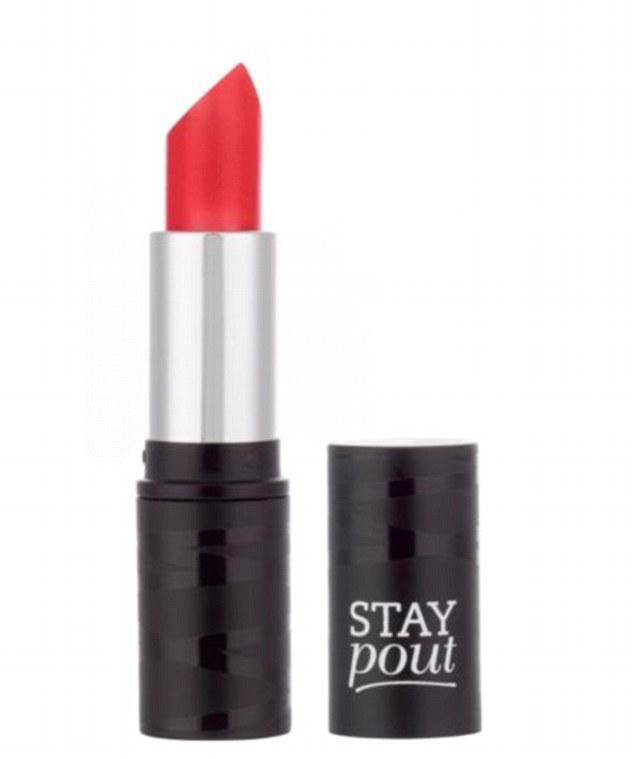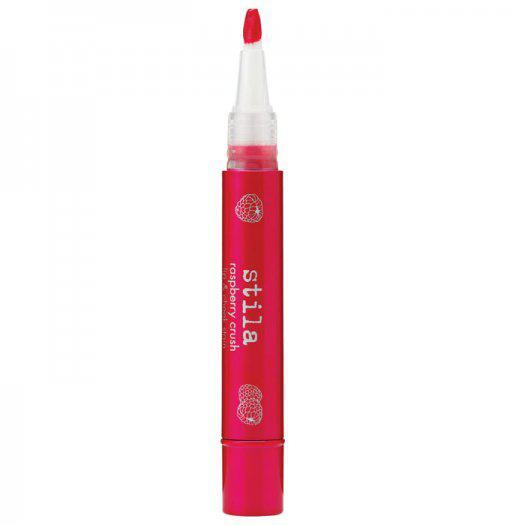The first image is the image on the left, the second image is the image on the right. Considering the images on both sides, is "The left image shows exactly one lipstick next to its cap." valid? Answer yes or no. Yes. The first image is the image on the left, the second image is the image on the right. Evaluate the accuracy of this statement regarding the images: "The left image shows one lipstick next to its cap.". Is it true? Answer yes or no. Yes. 